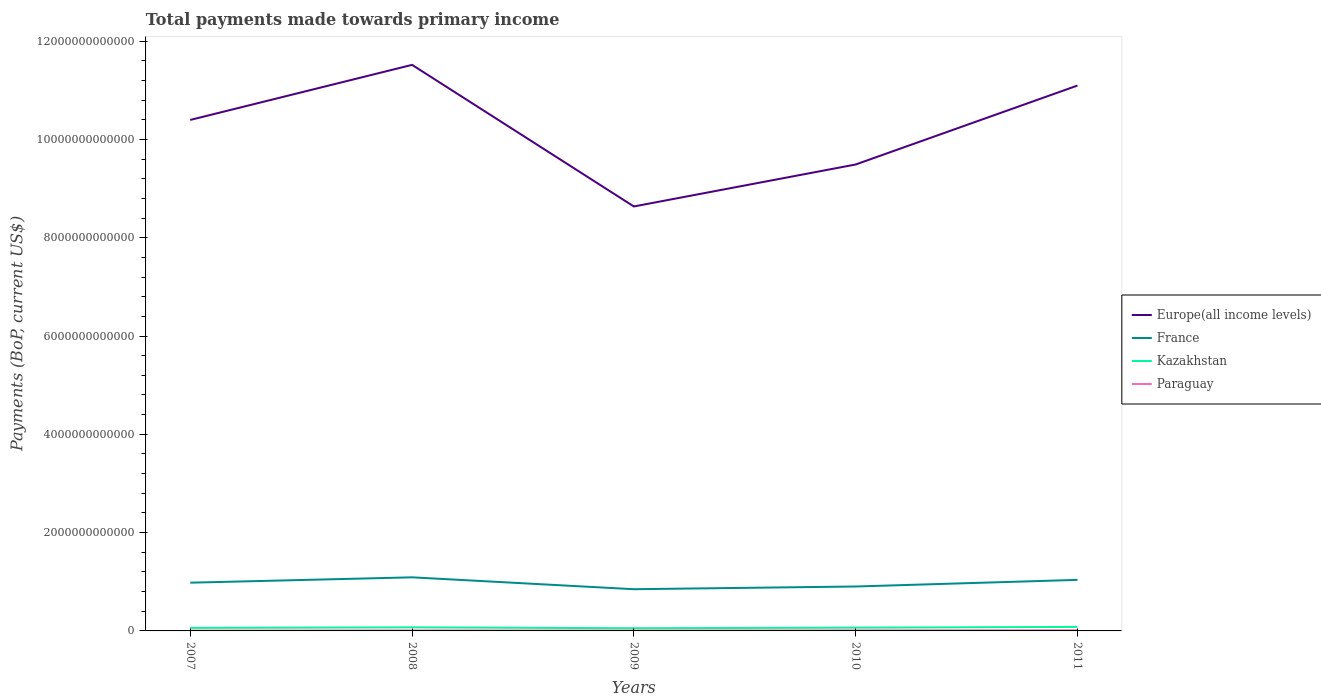How many different coloured lines are there?
Offer a very short reply. 4. Does the line corresponding to Europe(all income levels) intersect with the line corresponding to France?
Make the answer very short. No. Across all years, what is the maximum total payments made towards primary income in Europe(all income levels)?
Make the answer very short. 8.64e+12. What is the total total payments made towards primary income in Paraguay in the graph?
Offer a very short reply. -6.38e+09. What is the difference between the highest and the second highest total payments made towards primary income in Paraguay?
Keep it short and to the point. 6.38e+09. What is the difference between two consecutive major ticks on the Y-axis?
Your answer should be very brief. 2.00e+12. Where does the legend appear in the graph?
Give a very brief answer. Center right. How are the legend labels stacked?
Keep it short and to the point. Vertical. What is the title of the graph?
Ensure brevity in your answer.  Total payments made towards primary income. What is the label or title of the Y-axis?
Offer a terse response. Payments (BoP, current US$). What is the Payments (BoP, current US$) of Europe(all income levels) in 2007?
Offer a terse response. 1.04e+13. What is the Payments (BoP, current US$) of France in 2007?
Offer a very short reply. 9.81e+11. What is the Payments (BoP, current US$) in Kazakhstan in 2007?
Keep it short and to the point. 6.18e+1. What is the Payments (BoP, current US$) of Paraguay in 2007?
Your answer should be very brief. 7.56e+09. What is the Payments (BoP, current US$) of Europe(all income levels) in 2008?
Give a very brief answer. 1.15e+13. What is the Payments (BoP, current US$) of France in 2008?
Your answer should be very brief. 1.09e+12. What is the Payments (BoP, current US$) in Kazakhstan in 2008?
Your answer should be very brief. 7.27e+1. What is the Payments (BoP, current US$) of Paraguay in 2008?
Offer a terse response. 1.05e+1. What is the Payments (BoP, current US$) of Europe(all income levels) in 2009?
Your response must be concise. 8.64e+12. What is the Payments (BoP, current US$) of France in 2009?
Offer a terse response. 8.49e+11. What is the Payments (BoP, current US$) in Kazakhstan in 2009?
Offer a very short reply. 5.46e+1. What is the Payments (BoP, current US$) of Paraguay in 2009?
Your answer should be compact. 8.42e+09. What is the Payments (BoP, current US$) in Europe(all income levels) in 2010?
Your answer should be very brief. 9.49e+12. What is the Payments (BoP, current US$) of France in 2010?
Offer a terse response. 9.04e+11. What is the Payments (BoP, current US$) of Kazakhstan in 2010?
Keep it short and to the point. 6.63e+1. What is the Payments (BoP, current US$) of Paraguay in 2010?
Give a very brief answer. 1.17e+1. What is the Payments (BoP, current US$) in Europe(all income levels) in 2011?
Keep it short and to the point. 1.11e+13. What is the Payments (BoP, current US$) in France in 2011?
Your answer should be compact. 1.04e+12. What is the Payments (BoP, current US$) in Kazakhstan in 2011?
Your answer should be very brief. 8.13e+1. What is the Payments (BoP, current US$) of Paraguay in 2011?
Your answer should be compact. 1.39e+1. Across all years, what is the maximum Payments (BoP, current US$) in Europe(all income levels)?
Make the answer very short. 1.15e+13. Across all years, what is the maximum Payments (BoP, current US$) in France?
Your answer should be very brief. 1.09e+12. Across all years, what is the maximum Payments (BoP, current US$) in Kazakhstan?
Keep it short and to the point. 8.13e+1. Across all years, what is the maximum Payments (BoP, current US$) in Paraguay?
Your answer should be compact. 1.39e+1. Across all years, what is the minimum Payments (BoP, current US$) of Europe(all income levels)?
Offer a terse response. 8.64e+12. Across all years, what is the minimum Payments (BoP, current US$) in France?
Provide a short and direct response. 8.49e+11. Across all years, what is the minimum Payments (BoP, current US$) of Kazakhstan?
Keep it short and to the point. 5.46e+1. Across all years, what is the minimum Payments (BoP, current US$) of Paraguay?
Make the answer very short. 7.56e+09. What is the total Payments (BoP, current US$) of Europe(all income levels) in the graph?
Provide a short and direct response. 5.11e+13. What is the total Payments (BoP, current US$) of France in the graph?
Your answer should be compact. 4.86e+12. What is the total Payments (BoP, current US$) of Kazakhstan in the graph?
Make the answer very short. 3.37e+11. What is the total Payments (BoP, current US$) of Paraguay in the graph?
Make the answer very short. 5.22e+1. What is the difference between the Payments (BoP, current US$) in Europe(all income levels) in 2007 and that in 2008?
Give a very brief answer. -1.12e+12. What is the difference between the Payments (BoP, current US$) in France in 2007 and that in 2008?
Offer a very short reply. -1.09e+11. What is the difference between the Payments (BoP, current US$) of Kazakhstan in 2007 and that in 2008?
Ensure brevity in your answer.  -1.09e+1. What is the difference between the Payments (BoP, current US$) of Paraguay in 2007 and that in 2008?
Provide a succinct answer. -2.94e+09. What is the difference between the Payments (BoP, current US$) of Europe(all income levels) in 2007 and that in 2009?
Your answer should be compact. 1.76e+12. What is the difference between the Payments (BoP, current US$) in France in 2007 and that in 2009?
Give a very brief answer. 1.33e+11. What is the difference between the Payments (BoP, current US$) of Kazakhstan in 2007 and that in 2009?
Provide a succinct answer. 7.15e+09. What is the difference between the Payments (BoP, current US$) in Paraguay in 2007 and that in 2009?
Your answer should be compact. -8.59e+08. What is the difference between the Payments (BoP, current US$) in Europe(all income levels) in 2007 and that in 2010?
Give a very brief answer. 9.07e+11. What is the difference between the Payments (BoP, current US$) of France in 2007 and that in 2010?
Give a very brief answer. 7.74e+1. What is the difference between the Payments (BoP, current US$) of Kazakhstan in 2007 and that in 2010?
Ensure brevity in your answer.  -4.59e+09. What is the difference between the Payments (BoP, current US$) in Paraguay in 2007 and that in 2010?
Offer a very short reply. -4.19e+09. What is the difference between the Payments (BoP, current US$) of Europe(all income levels) in 2007 and that in 2011?
Offer a terse response. -6.99e+11. What is the difference between the Payments (BoP, current US$) of France in 2007 and that in 2011?
Your answer should be compact. -5.73e+1. What is the difference between the Payments (BoP, current US$) of Kazakhstan in 2007 and that in 2011?
Provide a succinct answer. -1.96e+1. What is the difference between the Payments (BoP, current US$) of Paraguay in 2007 and that in 2011?
Provide a short and direct response. -6.38e+09. What is the difference between the Payments (BoP, current US$) of Europe(all income levels) in 2008 and that in 2009?
Ensure brevity in your answer.  2.88e+12. What is the difference between the Payments (BoP, current US$) in France in 2008 and that in 2009?
Make the answer very short. 2.42e+11. What is the difference between the Payments (BoP, current US$) in Kazakhstan in 2008 and that in 2009?
Give a very brief answer. 1.81e+1. What is the difference between the Payments (BoP, current US$) in Paraguay in 2008 and that in 2009?
Your answer should be very brief. 2.09e+09. What is the difference between the Payments (BoP, current US$) in Europe(all income levels) in 2008 and that in 2010?
Keep it short and to the point. 2.03e+12. What is the difference between the Payments (BoP, current US$) of France in 2008 and that in 2010?
Make the answer very short. 1.87e+11. What is the difference between the Payments (BoP, current US$) of Kazakhstan in 2008 and that in 2010?
Offer a very short reply. 6.35e+09. What is the difference between the Payments (BoP, current US$) of Paraguay in 2008 and that in 2010?
Provide a short and direct response. -1.24e+09. What is the difference between the Payments (BoP, current US$) of Europe(all income levels) in 2008 and that in 2011?
Give a very brief answer. 4.21e+11. What is the difference between the Payments (BoP, current US$) in France in 2008 and that in 2011?
Your answer should be compact. 5.19e+1. What is the difference between the Payments (BoP, current US$) in Kazakhstan in 2008 and that in 2011?
Your answer should be very brief. -8.61e+09. What is the difference between the Payments (BoP, current US$) in Paraguay in 2008 and that in 2011?
Your answer should be compact. -3.43e+09. What is the difference between the Payments (BoP, current US$) in Europe(all income levels) in 2009 and that in 2010?
Offer a very short reply. -8.54e+11. What is the difference between the Payments (BoP, current US$) of France in 2009 and that in 2010?
Your answer should be compact. -5.52e+1. What is the difference between the Payments (BoP, current US$) of Kazakhstan in 2009 and that in 2010?
Provide a short and direct response. -1.17e+1. What is the difference between the Payments (BoP, current US$) in Paraguay in 2009 and that in 2010?
Offer a very short reply. -3.33e+09. What is the difference between the Payments (BoP, current US$) in Europe(all income levels) in 2009 and that in 2011?
Your response must be concise. -2.46e+12. What is the difference between the Payments (BoP, current US$) in France in 2009 and that in 2011?
Offer a very short reply. -1.90e+11. What is the difference between the Payments (BoP, current US$) in Kazakhstan in 2009 and that in 2011?
Offer a terse response. -2.67e+1. What is the difference between the Payments (BoP, current US$) of Paraguay in 2009 and that in 2011?
Keep it short and to the point. -5.52e+09. What is the difference between the Payments (BoP, current US$) of Europe(all income levels) in 2010 and that in 2011?
Offer a very short reply. -1.61e+12. What is the difference between the Payments (BoP, current US$) of France in 2010 and that in 2011?
Ensure brevity in your answer.  -1.35e+11. What is the difference between the Payments (BoP, current US$) of Kazakhstan in 2010 and that in 2011?
Your response must be concise. -1.50e+1. What is the difference between the Payments (BoP, current US$) of Paraguay in 2010 and that in 2011?
Offer a terse response. -2.19e+09. What is the difference between the Payments (BoP, current US$) of Europe(all income levels) in 2007 and the Payments (BoP, current US$) of France in 2008?
Your answer should be very brief. 9.31e+12. What is the difference between the Payments (BoP, current US$) in Europe(all income levels) in 2007 and the Payments (BoP, current US$) in Kazakhstan in 2008?
Ensure brevity in your answer.  1.03e+13. What is the difference between the Payments (BoP, current US$) of Europe(all income levels) in 2007 and the Payments (BoP, current US$) of Paraguay in 2008?
Your answer should be very brief. 1.04e+13. What is the difference between the Payments (BoP, current US$) of France in 2007 and the Payments (BoP, current US$) of Kazakhstan in 2008?
Keep it short and to the point. 9.08e+11. What is the difference between the Payments (BoP, current US$) in France in 2007 and the Payments (BoP, current US$) in Paraguay in 2008?
Provide a succinct answer. 9.71e+11. What is the difference between the Payments (BoP, current US$) in Kazakhstan in 2007 and the Payments (BoP, current US$) in Paraguay in 2008?
Your response must be concise. 5.12e+1. What is the difference between the Payments (BoP, current US$) of Europe(all income levels) in 2007 and the Payments (BoP, current US$) of France in 2009?
Make the answer very short. 9.55e+12. What is the difference between the Payments (BoP, current US$) of Europe(all income levels) in 2007 and the Payments (BoP, current US$) of Kazakhstan in 2009?
Your response must be concise. 1.03e+13. What is the difference between the Payments (BoP, current US$) in Europe(all income levels) in 2007 and the Payments (BoP, current US$) in Paraguay in 2009?
Provide a succinct answer. 1.04e+13. What is the difference between the Payments (BoP, current US$) of France in 2007 and the Payments (BoP, current US$) of Kazakhstan in 2009?
Your answer should be very brief. 9.27e+11. What is the difference between the Payments (BoP, current US$) of France in 2007 and the Payments (BoP, current US$) of Paraguay in 2009?
Offer a terse response. 9.73e+11. What is the difference between the Payments (BoP, current US$) in Kazakhstan in 2007 and the Payments (BoP, current US$) in Paraguay in 2009?
Ensure brevity in your answer.  5.33e+1. What is the difference between the Payments (BoP, current US$) of Europe(all income levels) in 2007 and the Payments (BoP, current US$) of France in 2010?
Keep it short and to the point. 9.49e+12. What is the difference between the Payments (BoP, current US$) of Europe(all income levels) in 2007 and the Payments (BoP, current US$) of Kazakhstan in 2010?
Your response must be concise. 1.03e+13. What is the difference between the Payments (BoP, current US$) in Europe(all income levels) in 2007 and the Payments (BoP, current US$) in Paraguay in 2010?
Make the answer very short. 1.04e+13. What is the difference between the Payments (BoP, current US$) in France in 2007 and the Payments (BoP, current US$) in Kazakhstan in 2010?
Keep it short and to the point. 9.15e+11. What is the difference between the Payments (BoP, current US$) in France in 2007 and the Payments (BoP, current US$) in Paraguay in 2010?
Your answer should be compact. 9.69e+11. What is the difference between the Payments (BoP, current US$) of Kazakhstan in 2007 and the Payments (BoP, current US$) of Paraguay in 2010?
Your answer should be very brief. 5.00e+1. What is the difference between the Payments (BoP, current US$) in Europe(all income levels) in 2007 and the Payments (BoP, current US$) in France in 2011?
Your answer should be very brief. 9.36e+12. What is the difference between the Payments (BoP, current US$) in Europe(all income levels) in 2007 and the Payments (BoP, current US$) in Kazakhstan in 2011?
Offer a very short reply. 1.03e+13. What is the difference between the Payments (BoP, current US$) in Europe(all income levels) in 2007 and the Payments (BoP, current US$) in Paraguay in 2011?
Your response must be concise. 1.04e+13. What is the difference between the Payments (BoP, current US$) of France in 2007 and the Payments (BoP, current US$) of Kazakhstan in 2011?
Your answer should be very brief. 9.00e+11. What is the difference between the Payments (BoP, current US$) of France in 2007 and the Payments (BoP, current US$) of Paraguay in 2011?
Give a very brief answer. 9.67e+11. What is the difference between the Payments (BoP, current US$) of Kazakhstan in 2007 and the Payments (BoP, current US$) of Paraguay in 2011?
Your response must be concise. 4.78e+1. What is the difference between the Payments (BoP, current US$) of Europe(all income levels) in 2008 and the Payments (BoP, current US$) of France in 2009?
Keep it short and to the point. 1.07e+13. What is the difference between the Payments (BoP, current US$) of Europe(all income levels) in 2008 and the Payments (BoP, current US$) of Kazakhstan in 2009?
Your answer should be compact. 1.15e+13. What is the difference between the Payments (BoP, current US$) of Europe(all income levels) in 2008 and the Payments (BoP, current US$) of Paraguay in 2009?
Offer a terse response. 1.15e+13. What is the difference between the Payments (BoP, current US$) in France in 2008 and the Payments (BoP, current US$) in Kazakhstan in 2009?
Your answer should be compact. 1.04e+12. What is the difference between the Payments (BoP, current US$) of France in 2008 and the Payments (BoP, current US$) of Paraguay in 2009?
Your answer should be very brief. 1.08e+12. What is the difference between the Payments (BoP, current US$) in Kazakhstan in 2008 and the Payments (BoP, current US$) in Paraguay in 2009?
Keep it short and to the point. 6.43e+1. What is the difference between the Payments (BoP, current US$) of Europe(all income levels) in 2008 and the Payments (BoP, current US$) of France in 2010?
Make the answer very short. 1.06e+13. What is the difference between the Payments (BoP, current US$) in Europe(all income levels) in 2008 and the Payments (BoP, current US$) in Kazakhstan in 2010?
Your answer should be very brief. 1.15e+13. What is the difference between the Payments (BoP, current US$) of Europe(all income levels) in 2008 and the Payments (BoP, current US$) of Paraguay in 2010?
Keep it short and to the point. 1.15e+13. What is the difference between the Payments (BoP, current US$) of France in 2008 and the Payments (BoP, current US$) of Kazakhstan in 2010?
Your response must be concise. 1.02e+12. What is the difference between the Payments (BoP, current US$) of France in 2008 and the Payments (BoP, current US$) of Paraguay in 2010?
Your response must be concise. 1.08e+12. What is the difference between the Payments (BoP, current US$) of Kazakhstan in 2008 and the Payments (BoP, current US$) of Paraguay in 2010?
Ensure brevity in your answer.  6.09e+1. What is the difference between the Payments (BoP, current US$) of Europe(all income levels) in 2008 and the Payments (BoP, current US$) of France in 2011?
Your answer should be very brief. 1.05e+13. What is the difference between the Payments (BoP, current US$) of Europe(all income levels) in 2008 and the Payments (BoP, current US$) of Kazakhstan in 2011?
Offer a terse response. 1.14e+13. What is the difference between the Payments (BoP, current US$) of Europe(all income levels) in 2008 and the Payments (BoP, current US$) of Paraguay in 2011?
Your answer should be compact. 1.15e+13. What is the difference between the Payments (BoP, current US$) of France in 2008 and the Payments (BoP, current US$) of Kazakhstan in 2011?
Provide a short and direct response. 1.01e+12. What is the difference between the Payments (BoP, current US$) of France in 2008 and the Payments (BoP, current US$) of Paraguay in 2011?
Offer a terse response. 1.08e+12. What is the difference between the Payments (BoP, current US$) of Kazakhstan in 2008 and the Payments (BoP, current US$) of Paraguay in 2011?
Your answer should be compact. 5.87e+1. What is the difference between the Payments (BoP, current US$) of Europe(all income levels) in 2009 and the Payments (BoP, current US$) of France in 2010?
Your answer should be very brief. 7.73e+12. What is the difference between the Payments (BoP, current US$) in Europe(all income levels) in 2009 and the Payments (BoP, current US$) in Kazakhstan in 2010?
Keep it short and to the point. 8.57e+12. What is the difference between the Payments (BoP, current US$) in Europe(all income levels) in 2009 and the Payments (BoP, current US$) in Paraguay in 2010?
Offer a very short reply. 8.62e+12. What is the difference between the Payments (BoP, current US$) of France in 2009 and the Payments (BoP, current US$) of Kazakhstan in 2010?
Make the answer very short. 7.82e+11. What is the difference between the Payments (BoP, current US$) in France in 2009 and the Payments (BoP, current US$) in Paraguay in 2010?
Make the answer very short. 8.37e+11. What is the difference between the Payments (BoP, current US$) in Kazakhstan in 2009 and the Payments (BoP, current US$) in Paraguay in 2010?
Provide a succinct answer. 4.28e+1. What is the difference between the Payments (BoP, current US$) in Europe(all income levels) in 2009 and the Payments (BoP, current US$) in France in 2011?
Make the answer very short. 7.60e+12. What is the difference between the Payments (BoP, current US$) of Europe(all income levels) in 2009 and the Payments (BoP, current US$) of Kazakhstan in 2011?
Offer a terse response. 8.55e+12. What is the difference between the Payments (BoP, current US$) in Europe(all income levels) in 2009 and the Payments (BoP, current US$) in Paraguay in 2011?
Offer a very short reply. 8.62e+12. What is the difference between the Payments (BoP, current US$) in France in 2009 and the Payments (BoP, current US$) in Kazakhstan in 2011?
Your response must be concise. 7.67e+11. What is the difference between the Payments (BoP, current US$) of France in 2009 and the Payments (BoP, current US$) of Paraguay in 2011?
Keep it short and to the point. 8.35e+11. What is the difference between the Payments (BoP, current US$) in Kazakhstan in 2009 and the Payments (BoP, current US$) in Paraguay in 2011?
Keep it short and to the point. 4.07e+1. What is the difference between the Payments (BoP, current US$) of Europe(all income levels) in 2010 and the Payments (BoP, current US$) of France in 2011?
Your answer should be compact. 8.45e+12. What is the difference between the Payments (BoP, current US$) of Europe(all income levels) in 2010 and the Payments (BoP, current US$) of Kazakhstan in 2011?
Ensure brevity in your answer.  9.41e+12. What is the difference between the Payments (BoP, current US$) in Europe(all income levels) in 2010 and the Payments (BoP, current US$) in Paraguay in 2011?
Make the answer very short. 9.48e+12. What is the difference between the Payments (BoP, current US$) of France in 2010 and the Payments (BoP, current US$) of Kazakhstan in 2011?
Give a very brief answer. 8.22e+11. What is the difference between the Payments (BoP, current US$) of France in 2010 and the Payments (BoP, current US$) of Paraguay in 2011?
Provide a short and direct response. 8.90e+11. What is the difference between the Payments (BoP, current US$) in Kazakhstan in 2010 and the Payments (BoP, current US$) in Paraguay in 2011?
Your answer should be very brief. 5.24e+1. What is the average Payments (BoP, current US$) of Europe(all income levels) per year?
Ensure brevity in your answer.  1.02e+13. What is the average Payments (BoP, current US$) in France per year?
Offer a very short reply. 9.72e+11. What is the average Payments (BoP, current US$) of Kazakhstan per year?
Your answer should be very brief. 6.73e+1. What is the average Payments (BoP, current US$) in Paraguay per year?
Your answer should be compact. 1.04e+1. In the year 2007, what is the difference between the Payments (BoP, current US$) in Europe(all income levels) and Payments (BoP, current US$) in France?
Ensure brevity in your answer.  9.41e+12. In the year 2007, what is the difference between the Payments (BoP, current US$) of Europe(all income levels) and Payments (BoP, current US$) of Kazakhstan?
Ensure brevity in your answer.  1.03e+13. In the year 2007, what is the difference between the Payments (BoP, current US$) of Europe(all income levels) and Payments (BoP, current US$) of Paraguay?
Make the answer very short. 1.04e+13. In the year 2007, what is the difference between the Payments (BoP, current US$) in France and Payments (BoP, current US$) in Kazakhstan?
Provide a succinct answer. 9.19e+11. In the year 2007, what is the difference between the Payments (BoP, current US$) in France and Payments (BoP, current US$) in Paraguay?
Provide a succinct answer. 9.74e+11. In the year 2007, what is the difference between the Payments (BoP, current US$) in Kazakhstan and Payments (BoP, current US$) in Paraguay?
Provide a succinct answer. 5.42e+1. In the year 2008, what is the difference between the Payments (BoP, current US$) of Europe(all income levels) and Payments (BoP, current US$) of France?
Ensure brevity in your answer.  1.04e+13. In the year 2008, what is the difference between the Payments (BoP, current US$) of Europe(all income levels) and Payments (BoP, current US$) of Kazakhstan?
Ensure brevity in your answer.  1.14e+13. In the year 2008, what is the difference between the Payments (BoP, current US$) in Europe(all income levels) and Payments (BoP, current US$) in Paraguay?
Your answer should be very brief. 1.15e+13. In the year 2008, what is the difference between the Payments (BoP, current US$) of France and Payments (BoP, current US$) of Kazakhstan?
Provide a short and direct response. 1.02e+12. In the year 2008, what is the difference between the Payments (BoP, current US$) of France and Payments (BoP, current US$) of Paraguay?
Offer a very short reply. 1.08e+12. In the year 2008, what is the difference between the Payments (BoP, current US$) of Kazakhstan and Payments (BoP, current US$) of Paraguay?
Ensure brevity in your answer.  6.22e+1. In the year 2009, what is the difference between the Payments (BoP, current US$) in Europe(all income levels) and Payments (BoP, current US$) in France?
Offer a terse response. 7.79e+12. In the year 2009, what is the difference between the Payments (BoP, current US$) of Europe(all income levels) and Payments (BoP, current US$) of Kazakhstan?
Your response must be concise. 8.58e+12. In the year 2009, what is the difference between the Payments (BoP, current US$) in Europe(all income levels) and Payments (BoP, current US$) in Paraguay?
Your answer should be compact. 8.63e+12. In the year 2009, what is the difference between the Payments (BoP, current US$) in France and Payments (BoP, current US$) in Kazakhstan?
Make the answer very short. 7.94e+11. In the year 2009, what is the difference between the Payments (BoP, current US$) in France and Payments (BoP, current US$) in Paraguay?
Offer a very short reply. 8.40e+11. In the year 2009, what is the difference between the Payments (BoP, current US$) in Kazakhstan and Payments (BoP, current US$) in Paraguay?
Give a very brief answer. 4.62e+1. In the year 2010, what is the difference between the Payments (BoP, current US$) of Europe(all income levels) and Payments (BoP, current US$) of France?
Provide a succinct answer. 8.59e+12. In the year 2010, what is the difference between the Payments (BoP, current US$) of Europe(all income levels) and Payments (BoP, current US$) of Kazakhstan?
Give a very brief answer. 9.42e+12. In the year 2010, what is the difference between the Payments (BoP, current US$) of Europe(all income levels) and Payments (BoP, current US$) of Paraguay?
Offer a very short reply. 9.48e+12. In the year 2010, what is the difference between the Payments (BoP, current US$) in France and Payments (BoP, current US$) in Kazakhstan?
Your answer should be compact. 8.37e+11. In the year 2010, what is the difference between the Payments (BoP, current US$) in France and Payments (BoP, current US$) in Paraguay?
Give a very brief answer. 8.92e+11. In the year 2010, what is the difference between the Payments (BoP, current US$) of Kazakhstan and Payments (BoP, current US$) of Paraguay?
Your response must be concise. 5.46e+1. In the year 2011, what is the difference between the Payments (BoP, current US$) in Europe(all income levels) and Payments (BoP, current US$) in France?
Your response must be concise. 1.01e+13. In the year 2011, what is the difference between the Payments (BoP, current US$) in Europe(all income levels) and Payments (BoP, current US$) in Kazakhstan?
Provide a short and direct response. 1.10e+13. In the year 2011, what is the difference between the Payments (BoP, current US$) of Europe(all income levels) and Payments (BoP, current US$) of Paraguay?
Offer a very short reply. 1.11e+13. In the year 2011, what is the difference between the Payments (BoP, current US$) in France and Payments (BoP, current US$) in Kazakhstan?
Offer a very short reply. 9.57e+11. In the year 2011, what is the difference between the Payments (BoP, current US$) in France and Payments (BoP, current US$) in Paraguay?
Your response must be concise. 1.02e+12. In the year 2011, what is the difference between the Payments (BoP, current US$) in Kazakhstan and Payments (BoP, current US$) in Paraguay?
Provide a short and direct response. 6.74e+1. What is the ratio of the Payments (BoP, current US$) of Europe(all income levels) in 2007 to that in 2008?
Your response must be concise. 0.9. What is the ratio of the Payments (BoP, current US$) of France in 2007 to that in 2008?
Ensure brevity in your answer.  0.9. What is the ratio of the Payments (BoP, current US$) of Kazakhstan in 2007 to that in 2008?
Your response must be concise. 0.85. What is the ratio of the Payments (BoP, current US$) in Paraguay in 2007 to that in 2008?
Provide a succinct answer. 0.72. What is the ratio of the Payments (BoP, current US$) in Europe(all income levels) in 2007 to that in 2009?
Provide a short and direct response. 1.2. What is the ratio of the Payments (BoP, current US$) in France in 2007 to that in 2009?
Ensure brevity in your answer.  1.16. What is the ratio of the Payments (BoP, current US$) in Kazakhstan in 2007 to that in 2009?
Keep it short and to the point. 1.13. What is the ratio of the Payments (BoP, current US$) of Paraguay in 2007 to that in 2009?
Your answer should be very brief. 0.9. What is the ratio of the Payments (BoP, current US$) of Europe(all income levels) in 2007 to that in 2010?
Offer a very short reply. 1.1. What is the ratio of the Payments (BoP, current US$) in France in 2007 to that in 2010?
Keep it short and to the point. 1.09. What is the ratio of the Payments (BoP, current US$) in Kazakhstan in 2007 to that in 2010?
Your response must be concise. 0.93. What is the ratio of the Payments (BoP, current US$) in Paraguay in 2007 to that in 2010?
Make the answer very short. 0.64. What is the ratio of the Payments (BoP, current US$) in Europe(all income levels) in 2007 to that in 2011?
Offer a very short reply. 0.94. What is the ratio of the Payments (BoP, current US$) of France in 2007 to that in 2011?
Your response must be concise. 0.94. What is the ratio of the Payments (BoP, current US$) in Kazakhstan in 2007 to that in 2011?
Offer a very short reply. 0.76. What is the ratio of the Payments (BoP, current US$) of Paraguay in 2007 to that in 2011?
Your response must be concise. 0.54. What is the ratio of the Payments (BoP, current US$) in Europe(all income levels) in 2008 to that in 2009?
Keep it short and to the point. 1.33. What is the ratio of the Payments (BoP, current US$) of France in 2008 to that in 2009?
Your answer should be compact. 1.28. What is the ratio of the Payments (BoP, current US$) in Kazakhstan in 2008 to that in 2009?
Offer a very short reply. 1.33. What is the ratio of the Payments (BoP, current US$) of Paraguay in 2008 to that in 2009?
Provide a short and direct response. 1.25. What is the ratio of the Payments (BoP, current US$) of Europe(all income levels) in 2008 to that in 2010?
Your response must be concise. 1.21. What is the ratio of the Payments (BoP, current US$) of France in 2008 to that in 2010?
Offer a very short reply. 1.21. What is the ratio of the Payments (BoP, current US$) in Kazakhstan in 2008 to that in 2010?
Provide a short and direct response. 1.1. What is the ratio of the Payments (BoP, current US$) in Paraguay in 2008 to that in 2010?
Your answer should be very brief. 0.89. What is the ratio of the Payments (BoP, current US$) in Europe(all income levels) in 2008 to that in 2011?
Ensure brevity in your answer.  1.04. What is the ratio of the Payments (BoP, current US$) in France in 2008 to that in 2011?
Your answer should be compact. 1.05. What is the ratio of the Payments (BoP, current US$) of Kazakhstan in 2008 to that in 2011?
Your answer should be compact. 0.89. What is the ratio of the Payments (BoP, current US$) of Paraguay in 2008 to that in 2011?
Your response must be concise. 0.75. What is the ratio of the Payments (BoP, current US$) of Europe(all income levels) in 2009 to that in 2010?
Keep it short and to the point. 0.91. What is the ratio of the Payments (BoP, current US$) of France in 2009 to that in 2010?
Your answer should be compact. 0.94. What is the ratio of the Payments (BoP, current US$) of Kazakhstan in 2009 to that in 2010?
Ensure brevity in your answer.  0.82. What is the ratio of the Payments (BoP, current US$) in Paraguay in 2009 to that in 2010?
Give a very brief answer. 0.72. What is the ratio of the Payments (BoP, current US$) of Europe(all income levels) in 2009 to that in 2011?
Give a very brief answer. 0.78. What is the ratio of the Payments (BoP, current US$) of France in 2009 to that in 2011?
Make the answer very short. 0.82. What is the ratio of the Payments (BoP, current US$) of Kazakhstan in 2009 to that in 2011?
Keep it short and to the point. 0.67. What is the ratio of the Payments (BoP, current US$) in Paraguay in 2009 to that in 2011?
Offer a terse response. 0.6. What is the ratio of the Payments (BoP, current US$) in Europe(all income levels) in 2010 to that in 2011?
Provide a succinct answer. 0.86. What is the ratio of the Payments (BoP, current US$) in France in 2010 to that in 2011?
Ensure brevity in your answer.  0.87. What is the ratio of the Payments (BoP, current US$) in Kazakhstan in 2010 to that in 2011?
Ensure brevity in your answer.  0.82. What is the ratio of the Payments (BoP, current US$) of Paraguay in 2010 to that in 2011?
Offer a very short reply. 0.84. What is the difference between the highest and the second highest Payments (BoP, current US$) in Europe(all income levels)?
Ensure brevity in your answer.  4.21e+11. What is the difference between the highest and the second highest Payments (BoP, current US$) in France?
Your answer should be compact. 5.19e+1. What is the difference between the highest and the second highest Payments (BoP, current US$) in Kazakhstan?
Provide a succinct answer. 8.61e+09. What is the difference between the highest and the second highest Payments (BoP, current US$) of Paraguay?
Make the answer very short. 2.19e+09. What is the difference between the highest and the lowest Payments (BoP, current US$) in Europe(all income levels)?
Provide a short and direct response. 2.88e+12. What is the difference between the highest and the lowest Payments (BoP, current US$) in France?
Your response must be concise. 2.42e+11. What is the difference between the highest and the lowest Payments (BoP, current US$) of Kazakhstan?
Offer a terse response. 2.67e+1. What is the difference between the highest and the lowest Payments (BoP, current US$) of Paraguay?
Provide a succinct answer. 6.38e+09. 